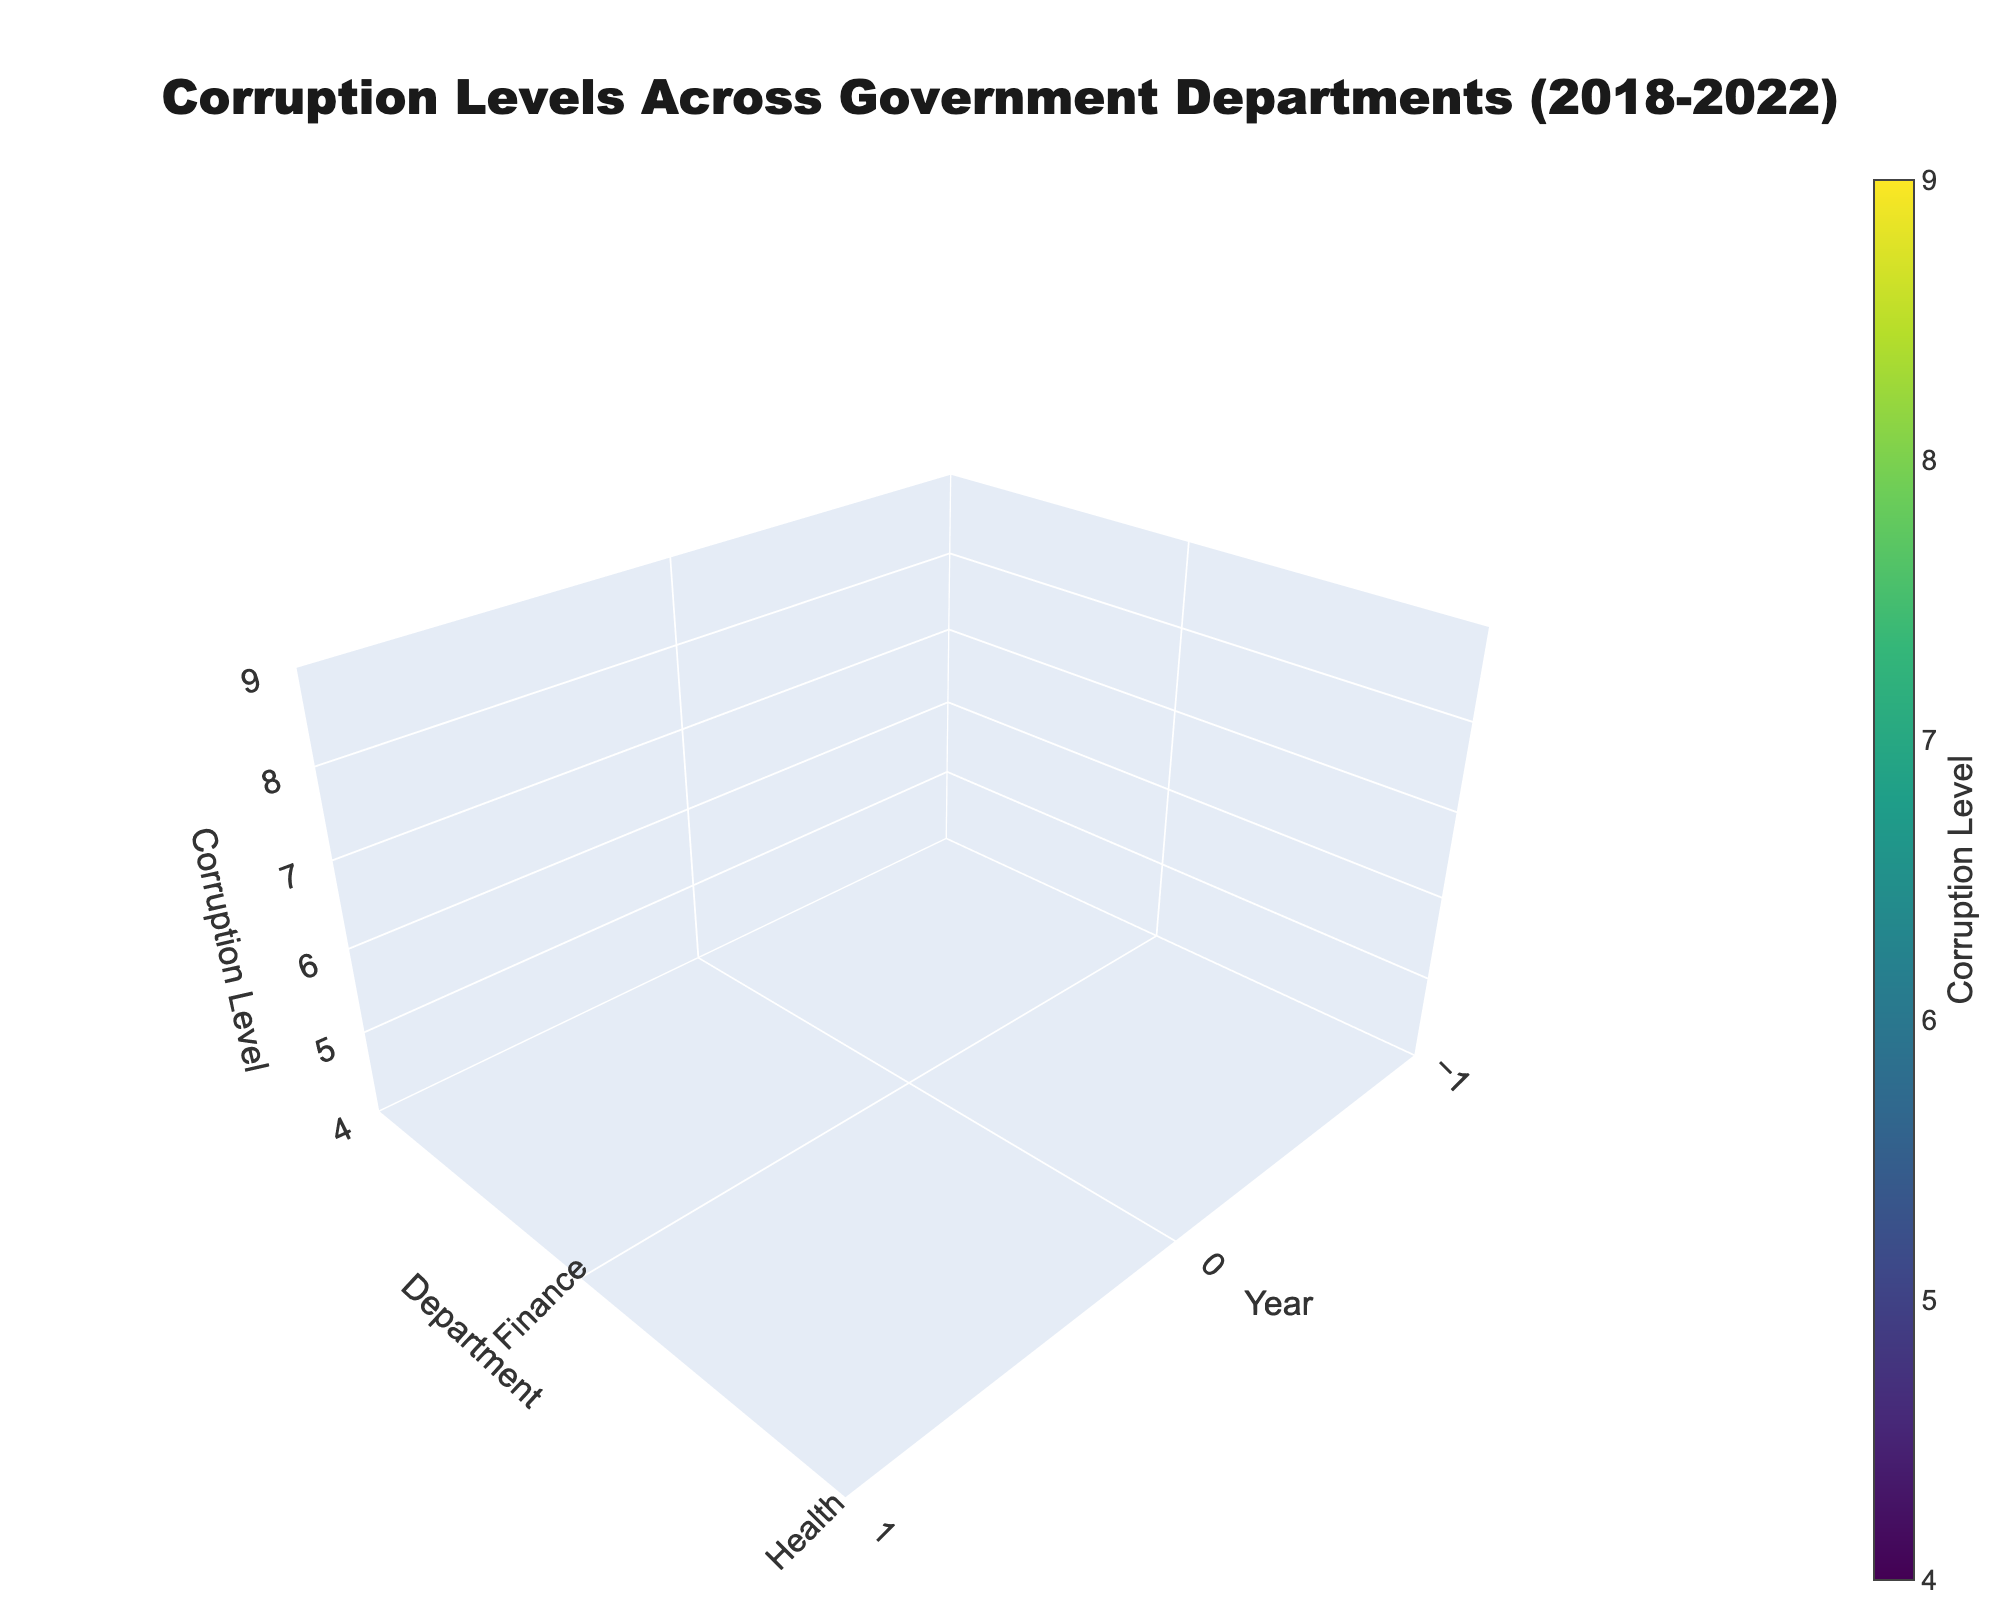What is the title of the figure? The title is prominently displayed at the top of the figure, stating the main topic being visualized.
Answer: Corruption Levels Across Government Departments (2018-2022) What departments are shown in the plot? The y-axis labeled 'Department' lists all the government departments being analyzed in the figure.
Answer: Finance, Health, Education, Transportation, Defense In which year did the Finance Department have the highest corruption level? By following the z-axis values for the Finance department and observing for the maximum peak, we can identify the year with the highest level.
Answer: 2022 Which department had the lowest corruption level in the year 2020? Compare the corruption levels shown along the z-axis for all departments in 2020 and identify the lowest value.
Answer: Education What is the corruption trend in the Defense Department from 2018 to 2022? By observing the z-axis levels and how they change for the Defense department from 2018 through 2022, we can describe the trend.
Answer: Increasing Comparing the Health and Transportation departments in 2021, which had a higher corruption level? Observe the z-axis values for both Health and Transportation departments in 2021 and compare the two.
Answer: Transportation What was the average corruption level across all departments in 2019? Sum the corruption levels for all departments in 2019 and divide by the number of departments (5) to find the average.
Answer: (7.5 + 5.5 + 4.1 + 6.8 + 8.3) / 5 = 32.2 / 5 = 6.44 By how much did the corruption level in the Finance Department increase from 2018 to 2022? Subtract the corruption level of the Finance department in 2018 from its corruption level in 2022.
Answer: 8.3 - 7.2 = 1.1 In 2022, which department had the highest corruption level, and what was its value? By observing the z-axis in 2022, identify the department at the highest point and note its corruption level value.
Answer: Defense, 8.9 